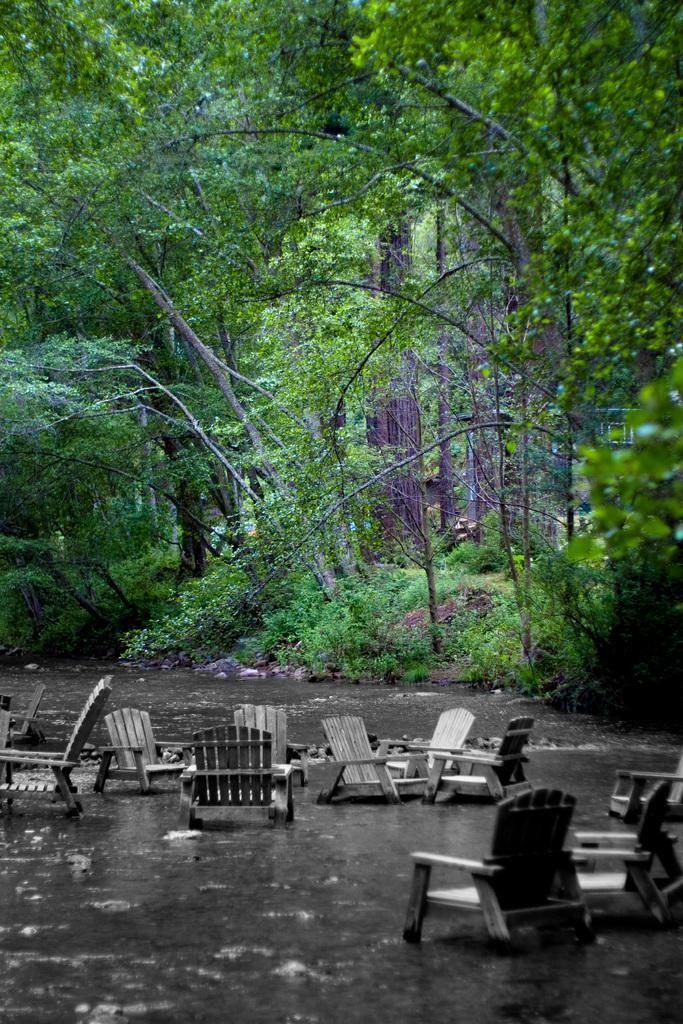What is the main subject of the image? The main subject of the image is a group of chairs. Where are the chairs located? The chairs are on water. What type of vegetation is visible in the image? There is grass visible in the image. What can be seen in the background of the image? There are trees in the background of the image. How many spoons are visible in the image? There are no spoons present in the image. What type of stitch is being used to hold the chairs together in the image? The chairs are not held together by any stitch; they are separate chairs floating on water. 